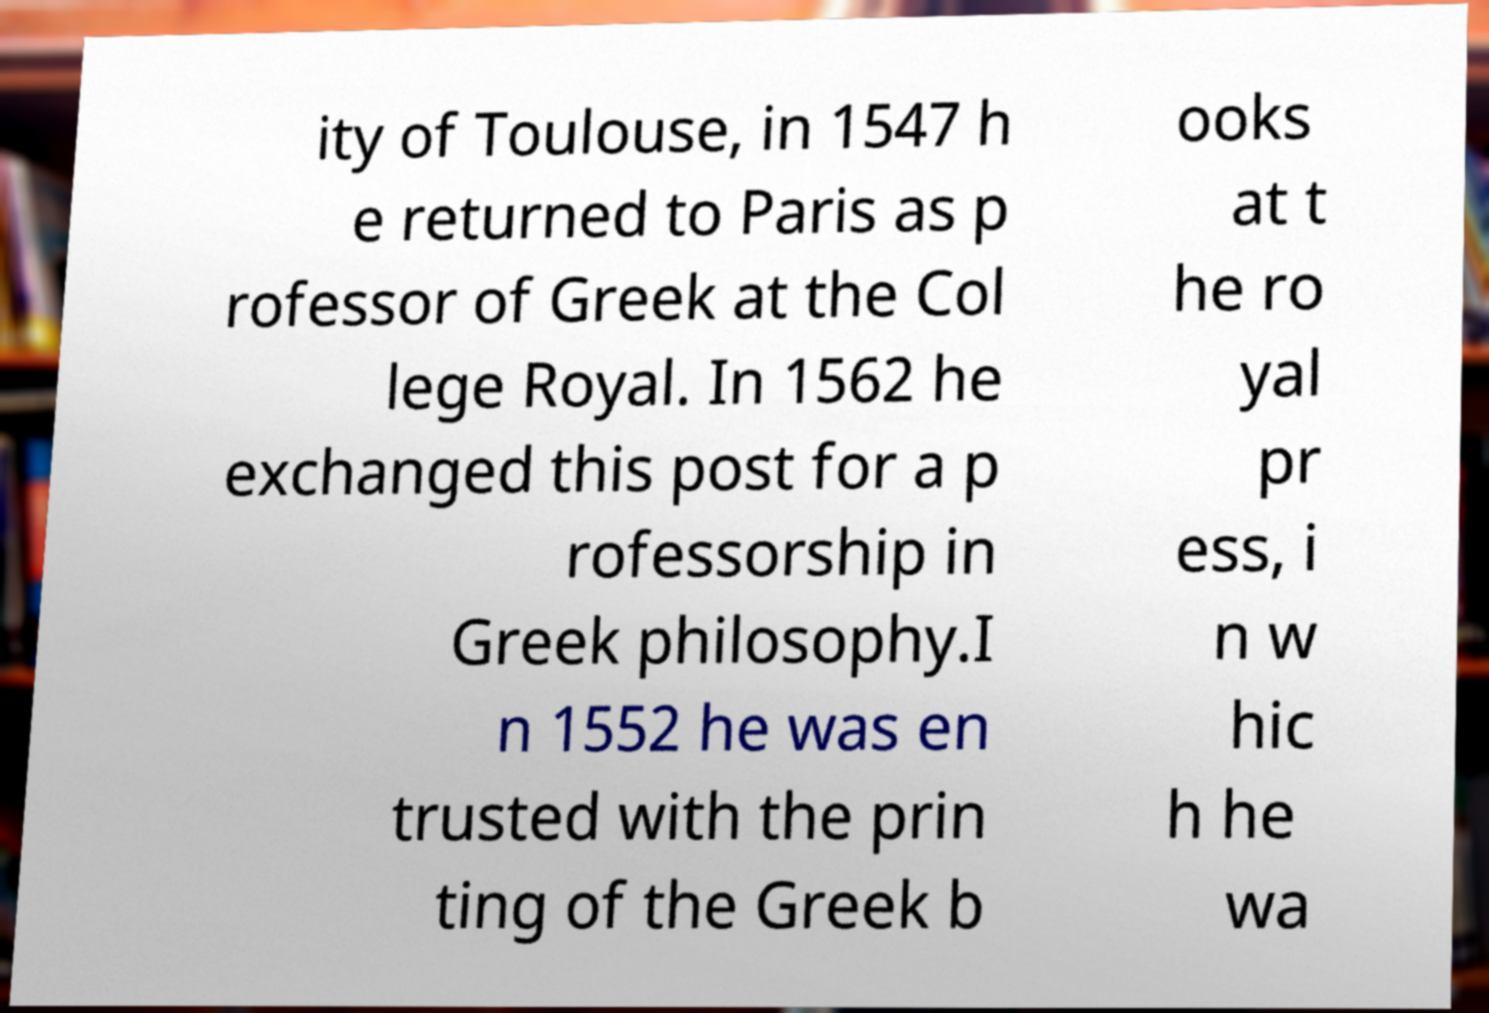What messages or text are displayed in this image? I need them in a readable, typed format. ity of Toulouse, in 1547 h e returned to Paris as p rofessor of Greek at the Col lege Royal. In 1562 he exchanged this post for a p rofessorship in Greek philosophy.I n 1552 he was en trusted with the prin ting of the Greek b ooks at t he ro yal pr ess, i n w hic h he wa 